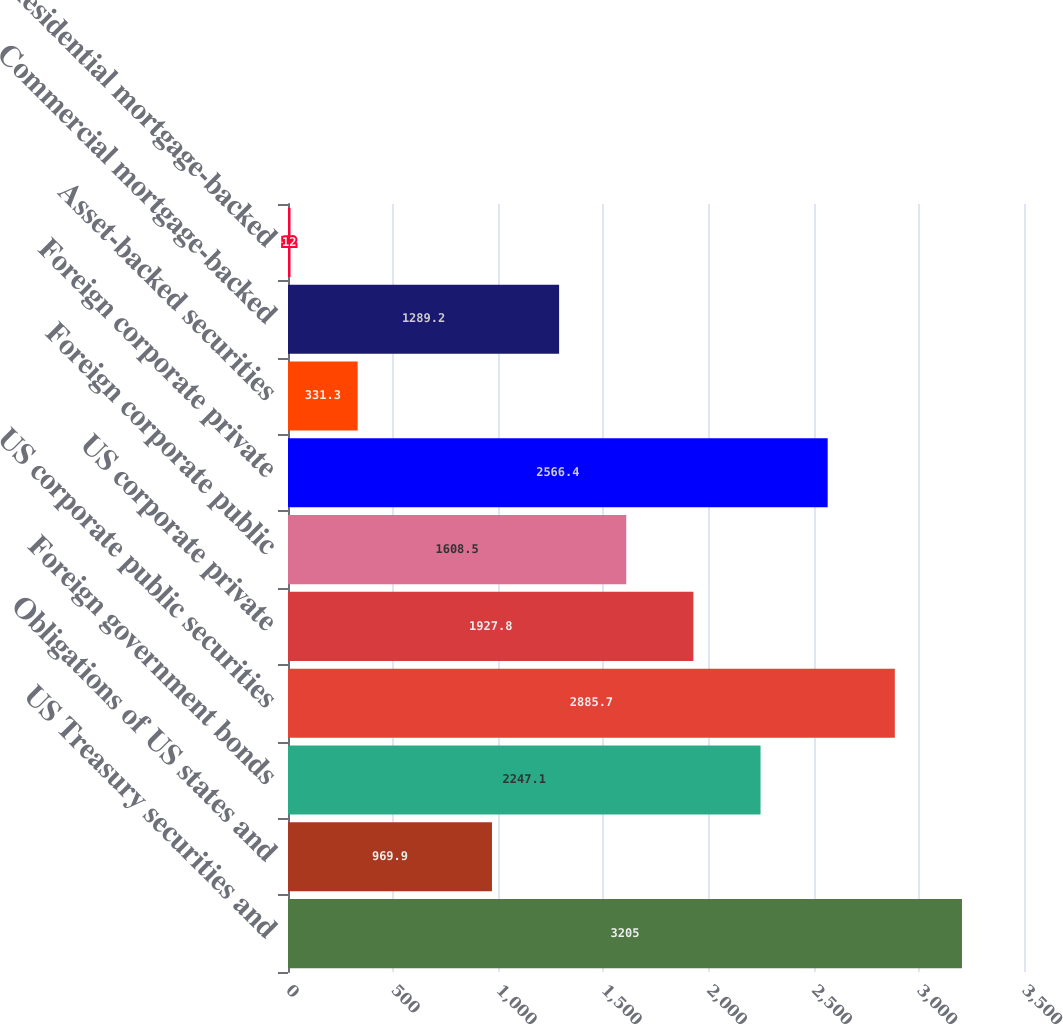Convert chart. <chart><loc_0><loc_0><loc_500><loc_500><bar_chart><fcel>US Treasury securities and<fcel>Obligations of US states and<fcel>Foreign government bonds<fcel>US corporate public securities<fcel>US corporate private<fcel>Foreign corporate public<fcel>Foreign corporate private<fcel>Asset-backed securities<fcel>Commercial mortgage-backed<fcel>Residential mortgage-backed<nl><fcel>3205<fcel>969.9<fcel>2247.1<fcel>2885.7<fcel>1927.8<fcel>1608.5<fcel>2566.4<fcel>331.3<fcel>1289.2<fcel>12<nl></chart> 